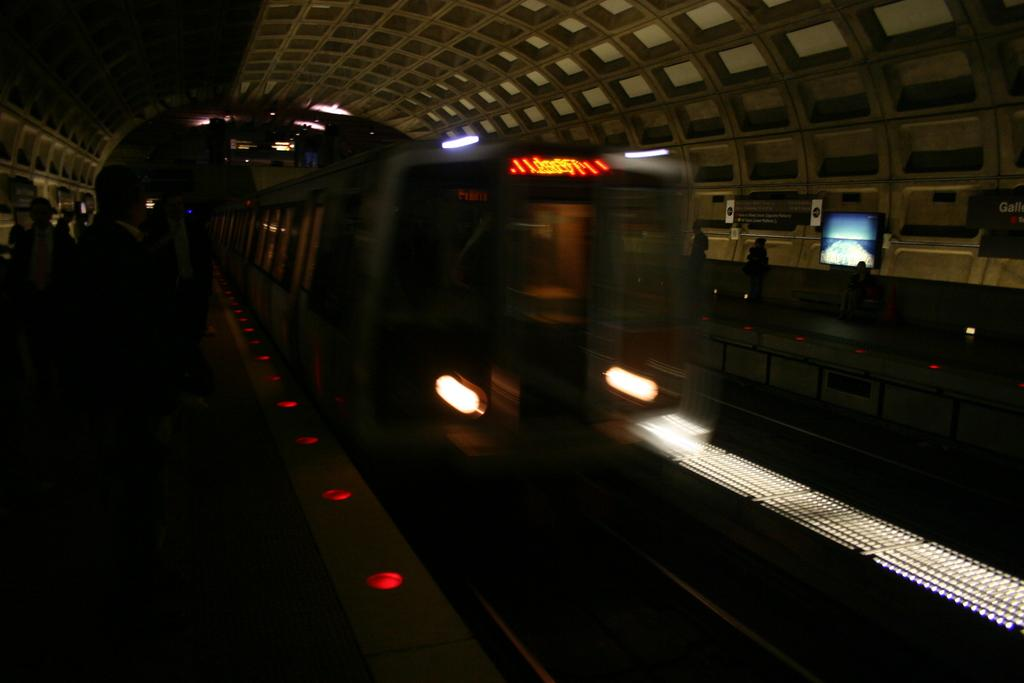What is the main feature of the image? There is a tunnel in the image. What is inside the tunnel? There is a train in the tunnel. How is the train positioned in the image? The train is moving on a track. What type of sock is hanging from the train's wing in the image? There is no sock or wing present on the train in the image. 